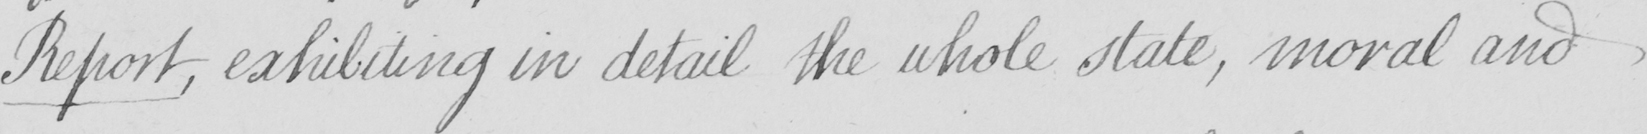Please transcribe the handwritten text in this image. Report , exhibiting in detail the whole state , moral and 